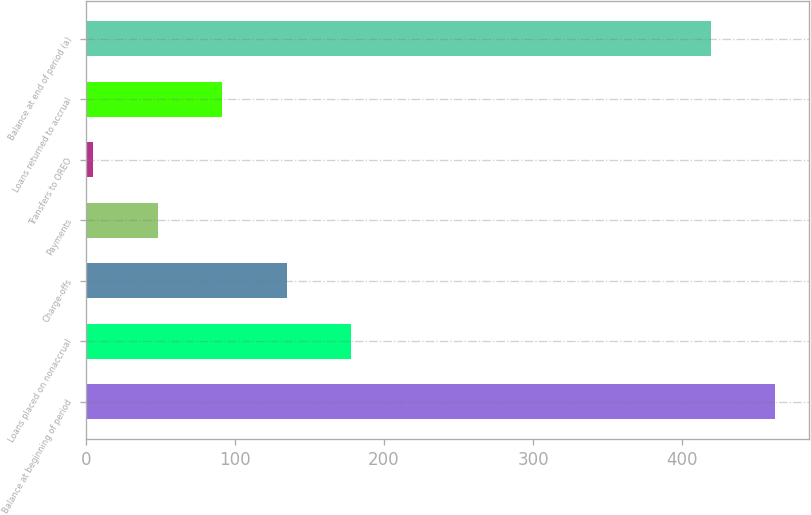Convert chart. <chart><loc_0><loc_0><loc_500><loc_500><bar_chart><fcel>Balance at beginning of period<fcel>Loans placed on nonaccrual<fcel>Charge-offs<fcel>Payments<fcel>Transfers to OREO<fcel>Loans returned to accrual<fcel>Balance at end of period (a)<nl><fcel>462.2<fcel>177.8<fcel>134.6<fcel>48.2<fcel>5<fcel>91.4<fcel>419<nl></chart> 